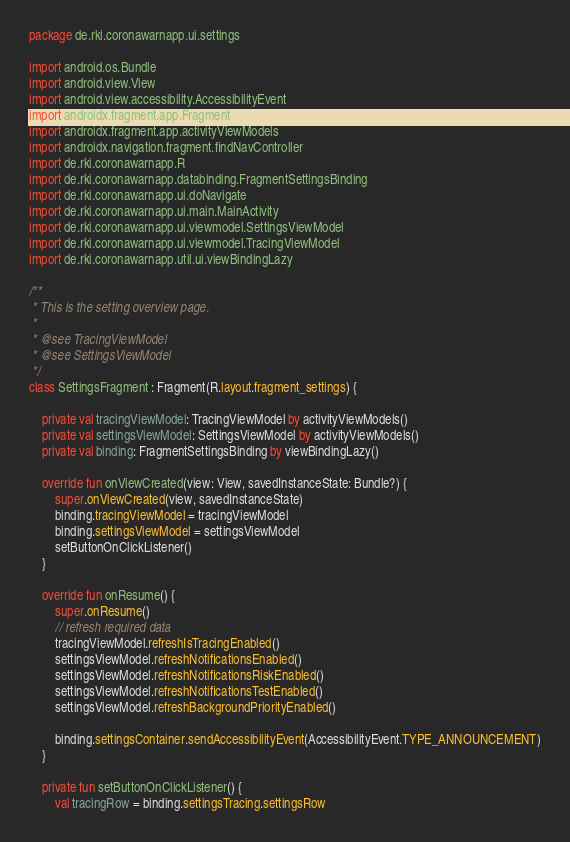Convert code to text. <code><loc_0><loc_0><loc_500><loc_500><_Kotlin_>package de.rki.coronawarnapp.ui.settings

import android.os.Bundle
import android.view.View
import android.view.accessibility.AccessibilityEvent
import androidx.fragment.app.Fragment
import androidx.fragment.app.activityViewModels
import androidx.navigation.fragment.findNavController
import de.rki.coronawarnapp.R
import de.rki.coronawarnapp.databinding.FragmentSettingsBinding
import de.rki.coronawarnapp.ui.doNavigate
import de.rki.coronawarnapp.ui.main.MainActivity
import de.rki.coronawarnapp.ui.viewmodel.SettingsViewModel
import de.rki.coronawarnapp.ui.viewmodel.TracingViewModel
import de.rki.coronawarnapp.util.ui.viewBindingLazy

/**
 * This is the setting overview page.
 *
 * @see TracingViewModel
 * @see SettingsViewModel
 */
class SettingsFragment : Fragment(R.layout.fragment_settings) {

    private val tracingViewModel: TracingViewModel by activityViewModels()
    private val settingsViewModel: SettingsViewModel by activityViewModels()
    private val binding: FragmentSettingsBinding by viewBindingLazy()

    override fun onViewCreated(view: View, savedInstanceState: Bundle?) {
        super.onViewCreated(view, savedInstanceState)
        binding.tracingViewModel = tracingViewModel
        binding.settingsViewModel = settingsViewModel
        setButtonOnClickListener()
    }

    override fun onResume() {
        super.onResume()
        // refresh required data
        tracingViewModel.refreshIsTracingEnabled()
        settingsViewModel.refreshNotificationsEnabled()
        settingsViewModel.refreshNotificationsRiskEnabled()
        settingsViewModel.refreshNotificationsTestEnabled()
        settingsViewModel.refreshBackgroundPriorityEnabled()

        binding.settingsContainer.sendAccessibilityEvent(AccessibilityEvent.TYPE_ANNOUNCEMENT)
    }

    private fun setButtonOnClickListener() {
        val tracingRow = binding.settingsTracing.settingsRow</code> 